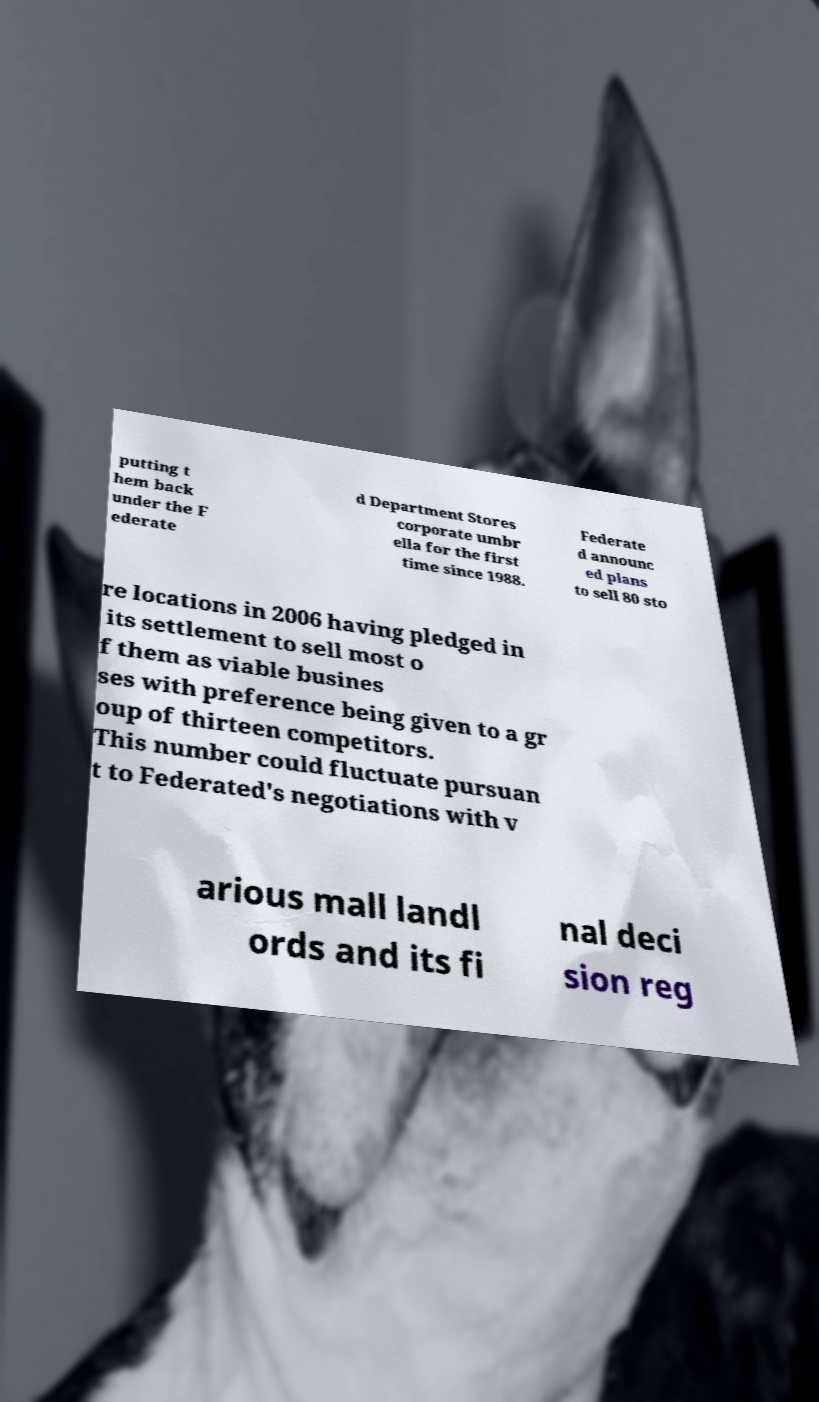I need the written content from this picture converted into text. Can you do that? putting t hem back under the F ederate d Department Stores corporate umbr ella for the first time since 1988. Federate d announc ed plans to sell 80 sto re locations in 2006 having pledged in its settlement to sell most o f them as viable busines ses with preference being given to a gr oup of thirteen competitors. This number could fluctuate pursuan t to Federated's negotiations with v arious mall landl ords and its fi nal deci sion reg 